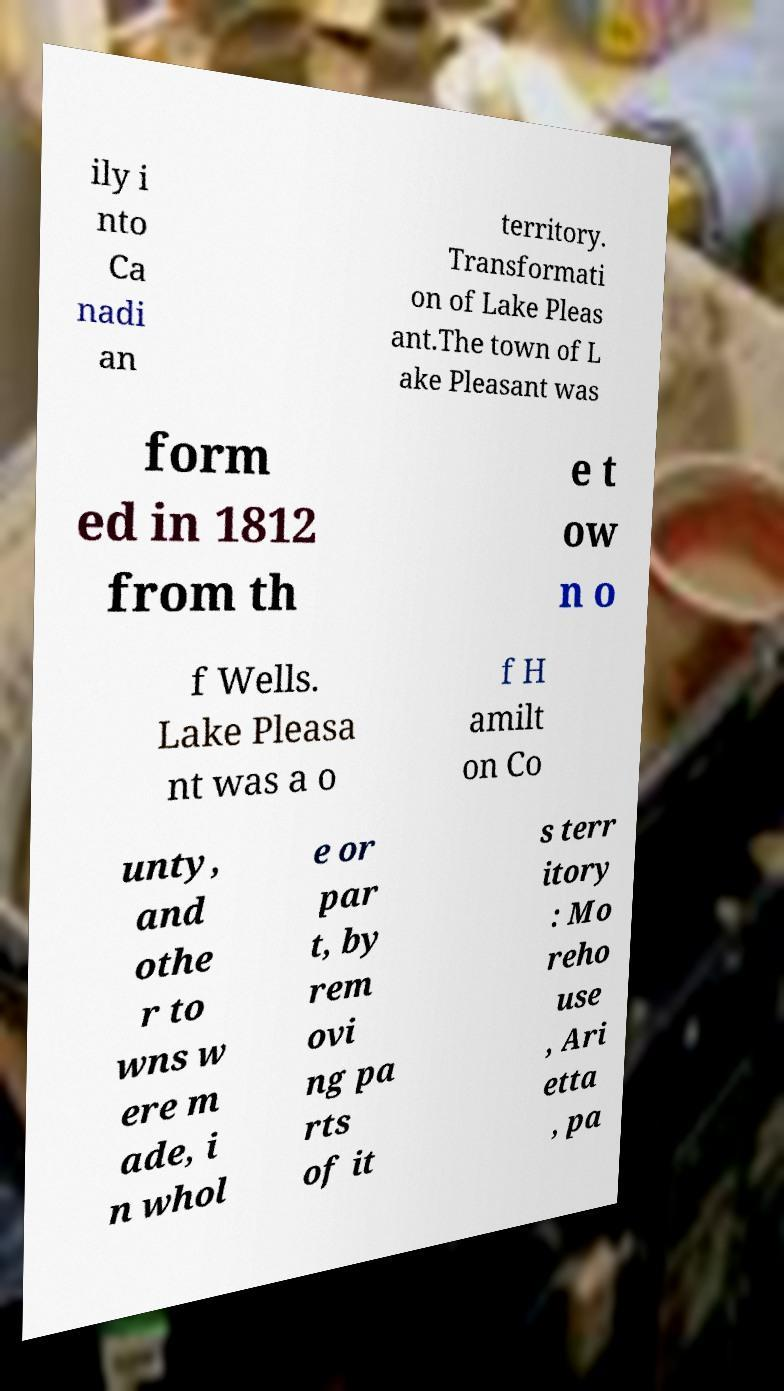Could you assist in decoding the text presented in this image and type it out clearly? ily i nto Ca nadi an territory. Transformati on of Lake Pleas ant.The town of L ake Pleasant was form ed in 1812 from th e t ow n o f Wells. Lake Pleasa nt was a o f H amilt on Co unty, and othe r to wns w ere m ade, i n whol e or par t, by rem ovi ng pa rts of it s terr itory : Mo reho use , Ari etta , pa 